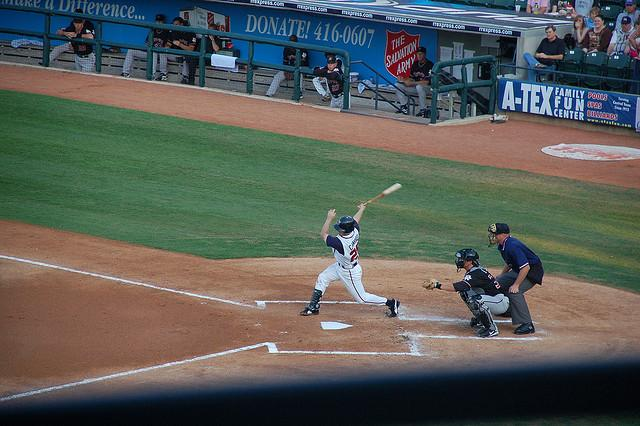Who is the man crouched behind the catcher?

Choices:
A) umpire
B) coach
C) batter
D) announcer umpire 